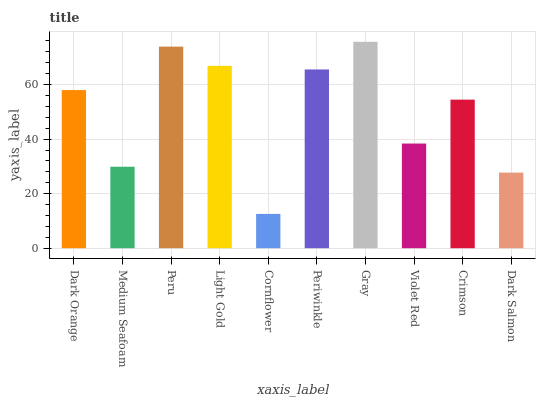Is Medium Seafoam the minimum?
Answer yes or no. No. Is Medium Seafoam the maximum?
Answer yes or no. No. Is Dark Orange greater than Medium Seafoam?
Answer yes or no. Yes. Is Medium Seafoam less than Dark Orange?
Answer yes or no. Yes. Is Medium Seafoam greater than Dark Orange?
Answer yes or no. No. Is Dark Orange less than Medium Seafoam?
Answer yes or no. No. Is Dark Orange the high median?
Answer yes or no. Yes. Is Crimson the low median?
Answer yes or no. Yes. Is Periwinkle the high median?
Answer yes or no. No. Is Dark Orange the low median?
Answer yes or no. No. 